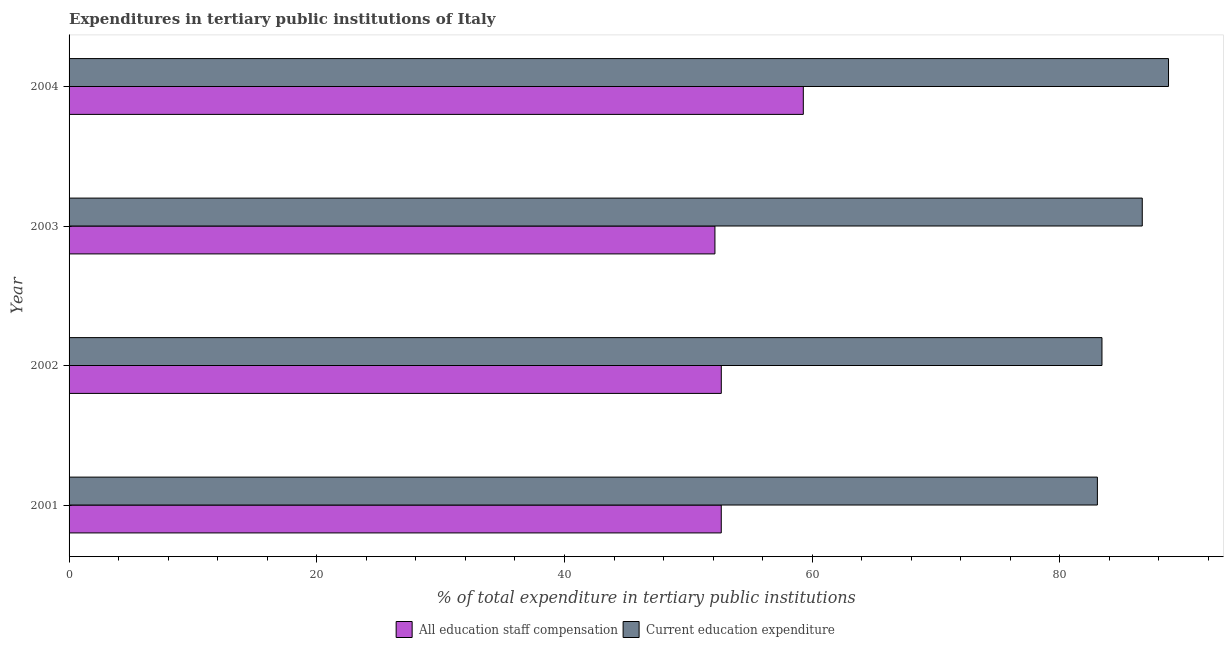How many different coloured bars are there?
Your response must be concise. 2. Are the number of bars per tick equal to the number of legend labels?
Offer a very short reply. Yes. How many bars are there on the 1st tick from the bottom?
Give a very brief answer. 2. In how many cases, is the number of bars for a given year not equal to the number of legend labels?
Provide a short and direct response. 0. What is the expenditure in staff compensation in 2001?
Offer a very short reply. 52.66. Across all years, what is the maximum expenditure in staff compensation?
Provide a short and direct response. 59.28. Across all years, what is the minimum expenditure in staff compensation?
Your answer should be very brief. 52.15. In which year was the expenditure in education maximum?
Make the answer very short. 2004. What is the total expenditure in education in the graph?
Keep it short and to the point. 341.85. What is the difference between the expenditure in staff compensation in 2001 and that in 2004?
Your answer should be very brief. -6.62. What is the difference between the expenditure in education in 2002 and the expenditure in staff compensation in 2003?
Provide a succinct answer. 31.25. What is the average expenditure in staff compensation per year?
Your answer should be very brief. 54.19. In the year 2004, what is the difference between the expenditure in staff compensation and expenditure in education?
Offer a terse response. -29.49. What is the ratio of the expenditure in staff compensation in 2003 to that in 2004?
Provide a succinct answer. 0.88. What is the difference between the highest and the second highest expenditure in education?
Make the answer very short. 2.12. What is the difference between the highest and the lowest expenditure in education?
Offer a terse response. 5.74. Is the sum of the expenditure in education in 2002 and 2003 greater than the maximum expenditure in staff compensation across all years?
Provide a short and direct response. Yes. What does the 1st bar from the top in 2003 represents?
Ensure brevity in your answer.  Current education expenditure. What does the 1st bar from the bottom in 2002 represents?
Keep it short and to the point. All education staff compensation. Are all the bars in the graph horizontal?
Make the answer very short. Yes. What is the difference between two consecutive major ticks on the X-axis?
Provide a short and direct response. 20. Are the values on the major ticks of X-axis written in scientific E-notation?
Your answer should be very brief. No. Does the graph contain grids?
Give a very brief answer. No. Where does the legend appear in the graph?
Provide a short and direct response. Bottom center. How many legend labels are there?
Provide a succinct answer. 2. What is the title of the graph?
Offer a very short reply. Expenditures in tertiary public institutions of Italy. What is the label or title of the X-axis?
Ensure brevity in your answer.  % of total expenditure in tertiary public institutions. What is the % of total expenditure in tertiary public institutions in All education staff compensation in 2001?
Offer a very short reply. 52.66. What is the % of total expenditure in tertiary public institutions in Current education expenditure in 2001?
Ensure brevity in your answer.  83.03. What is the % of total expenditure in tertiary public institutions in All education staff compensation in 2002?
Your response must be concise. 52.66. What is the % of total expenditure in tertiary public institutions in Current education expenditure in 2002?
Ensure brevity in your answer.  83.4. What is the % of total expenditure in tertiary public institutions of All education staff compensation in 2003?
Make the answer very short. 52.15. What is the % of total expenditure in tertiary public institutions in Current education expenditure in 2003?
Provide a short and direct response. 86.65. What is the % of total expenditure in tertiary public institutions of All education staff compensation in 2004?
Give a very brief answer. 59.28. What is the % of total expenditure in tertiary public institutions of Current education expenditure in 2004?
Make the answer very short. 88.77. Across all years, what is the maximum % of total expenditure in tertiary public institutions of All education staff compensation?
Your answer should be compact. 59.28. Across all years, what is the maximum % of total expenditure in tertiary public institutions of Current education expenditure?
Your response must be concise. 88.77. Across all years, what is the minimum % of total expenditure in tertiary public institutions in All education staff compensation?
Give a very brief answer. 52.15. Across all years, what is the minimum % of total expenditure in tertiary public institutions of Current education expenditure?
Make the answer very short. 83.03. What is the total % of total expenditure in tertiary public institutions of All education staff compensation in the graph?
Provide a succinct answer. 216.75. What is the total % of total expenditure in tertiary public institutions of Current education expenditure in the graph?
Give a very brief answer. 341.85. What is the difference between the % of total expenditure in tertiary public institutions of All education staff compensation in 2001 and that in 2002?
Provide a succinct answer. -0. What is the difference between the % of total expenditure in tertiary public institutions of Current education expenditure in 2001 and that in 2002?
Your response must be concise. -0.37. What is the difference between the % of total expenditure in tertiary public institutions in All education staff compensation in 2001 and that in 2003?
Your response must be concise. 0.51. What is the difference between the % of total expenditure in tertiary public institutions of Current education expenditure in 2001 and that in 2003?
Your answer should be very brief. -3.62. What is the difference between the % of total expenditure in tertiary public institutions of All education staff compensation in 2001 and that in 2004?
Give a very brief answer. -6.62. What is the difference between the % of total expenditure in tertiary public institutions of Current education expenditure in 2001 and that in 2004?
Offer a very short reply. -5.74. What is the difference between the % of total expenditure in tertiary public institutions in All education staff compensation in 2002 and that in 2003?
Keep it short and to the point. 0.51. What is the difference between the % of total expenditure in tertiary public institutions of Current education expenditure in 2002 and that in 2003?
Provide a succinct answer. -3.25. What is the difference between the % of total expenditure in tertiary public institutions in All education staff compensation in 2002 and that in 2004?
Make the answer very short. -6.62. What is the difference between the % of total expenditure in tertiary public institutions of Current education expenditure in 2002 and that in 2004?
Keep it short and to the point. -5.37. What is the difference between the % of total expenditure in tertiary public institutions in All education staff compensation in 2003 and that in 2004?
Your answer should be very brief. -7.13. What is the difference between the % of total expenditure in tertiary public institutions of Current education expenditure in 2003 and that in 2004?
Offer a terse response. -2.12. What is the difference between the % of total expenditure in tertiary public institutions of All education staff compensation in 2001 and the % of total expenditure in tertiary public institutions of Current education expenditure in 2002?
Offer a very short reply. -30.74. What is the difference between the % of total expenditure in tertiary public institutions in All education staff compensation in 2001 and the % of total expenditure in tertiary public institutions in Current education expenditure in 2003?
Provide a short and direct response. -33.99. What is the difference between the % of total expenditure in tertiary public institutions of All education staff compensation in 2001 and the % of total expenditure in tertiary public institutions of Current education expenditure in 2004?
Provide a succinct answer. -36.11. What is the difference between the % of total expenditure in tertiary public institutions of All education staff compensation in 2002 and the % of total expenditure in tertiary public institutions of Current education expenditure in 2003?
Provide a short and direct response. -33.99. What is the difference between the % of total expenditure in tertiary public institutions of All education staff compensation in 2002 and the % of total expenditure in tertiary public institutions of Current education expenditure in 2004?
Keep it short and to the point. -36.11. What is the difference between the % of total expenditure in tertiary public institutions in All education staff compensation in 2003 and the % of total expenditure in tertiary public institutions in Current education expenditure in 2004?
Ensure brevity in your answer.  -36.62. What is the average % of total expenditure in tertiary public institutions of All education staff compensation per year?
Offer a very short reply. 54.19. What is the average % of total expenditure in tertiary public institutions in Current education expenditure per year?
Offer a terse response. 85.46. In the year 2001, what is the difference between the % of total expenditure in tertiary public institutions in All education staff compensation and % of total expenditure in tertiary public institutions in Current education expenditure?
Ensure brevity in your answer.  -30.37. In the year 2002, what is the difference between the % of total expenditure in tertiary public institutions of All education staff compensation and % of total expenditure in tertiary public institutions of Current education expenditure?
Ensure brevity in your answer.  -30.74. In the year 2003, what is the difference between the % of total expenditure in tertiary public institutions in All education staff compensation and % of total expenditure in tertiary public institutions in Current education expenditure?
Make the answer very short. -34.5. In the year 2004, what is the difference between the % of total expenditure in tertiary public institutions of All education staff compensation and % of total expenditure in tertiary public institutions of Current education expenditure?
Offer a terse response. -29.49. What is the ratio of the % of total expenditure in tertiary public institutions of Current education expenditure in 2001 to that in 2002?
Keep it short and to the point. 1. What is the ratio of the % of total expenditure in tertiary public institutions in All education staff compensation in 2001 to that in 2003?
Offer a very short reply. 1.01. What is the ratio of the % of total expenditure in tertiary public institutions in Current education expenditure in 2001 to that in 2003?
Keep it short and to the point. 0.96. What is the ratio of the % of total expenditure in tertiary public institutions in All education staff compensation in 2001 to that in 2004?
Provide a succinct answer. 0.89. What is the ratio of the % of total expenditure in tertiary public institutions in Current education expenditure in 2001 to that in 2004?
Keep it short and to the point. 0.94. What is the ratio of the % of total expenditure in tertiary public institutions of All education staff compensation in 2002 to that in 2003?
Your answer should be very brief. 1.01. What is the ratio of the % of total expenditure in tertiary public institutions of Current education expenditure in 2002 to that in 2003?
Your response must be concise. 0.96. What is the ratio of the % of total expenditure in tertiary public institutions in All education staff compensation in 2002 to that in 2004?
Your answer should be compact. 0.89. What is the ratio of the % of total expenditure in tertiary public institutions in Current education expenditure in 2002 to that in 2004?
Your response must be concise. 0.94. What is the ratio of the % of total expenditure in tertiary public institutions of All education staff compensation in 2003 to that in 2004?
Your answer should be compact. 0.88. What is the ratio of the % of total expenditure in tertiary public institutions in Current education expenditure in 2003 to that in 2004?
Keep it short and to the point. 0.98. What is the difference between the highest and the second highest % of total expenditure in tertiary public institutions of All education staff compensation?
Your response must be concise. 6.62. What is the difference between the highest and the second highest % of total expenditure in tertiary public institutions of Current education expenditure?
Your answer should be compact. 2.12. What is the difference between the highest and the lowest % of total expenditure in tertiary public institutions in All education staff compensation?
Provide a short and direct response. 7.13. What is the difference between the highest and the lowest % of total expenditure in tertiary public institutions of Current education expenditure?
Provide a succinct answer. 5.74. 